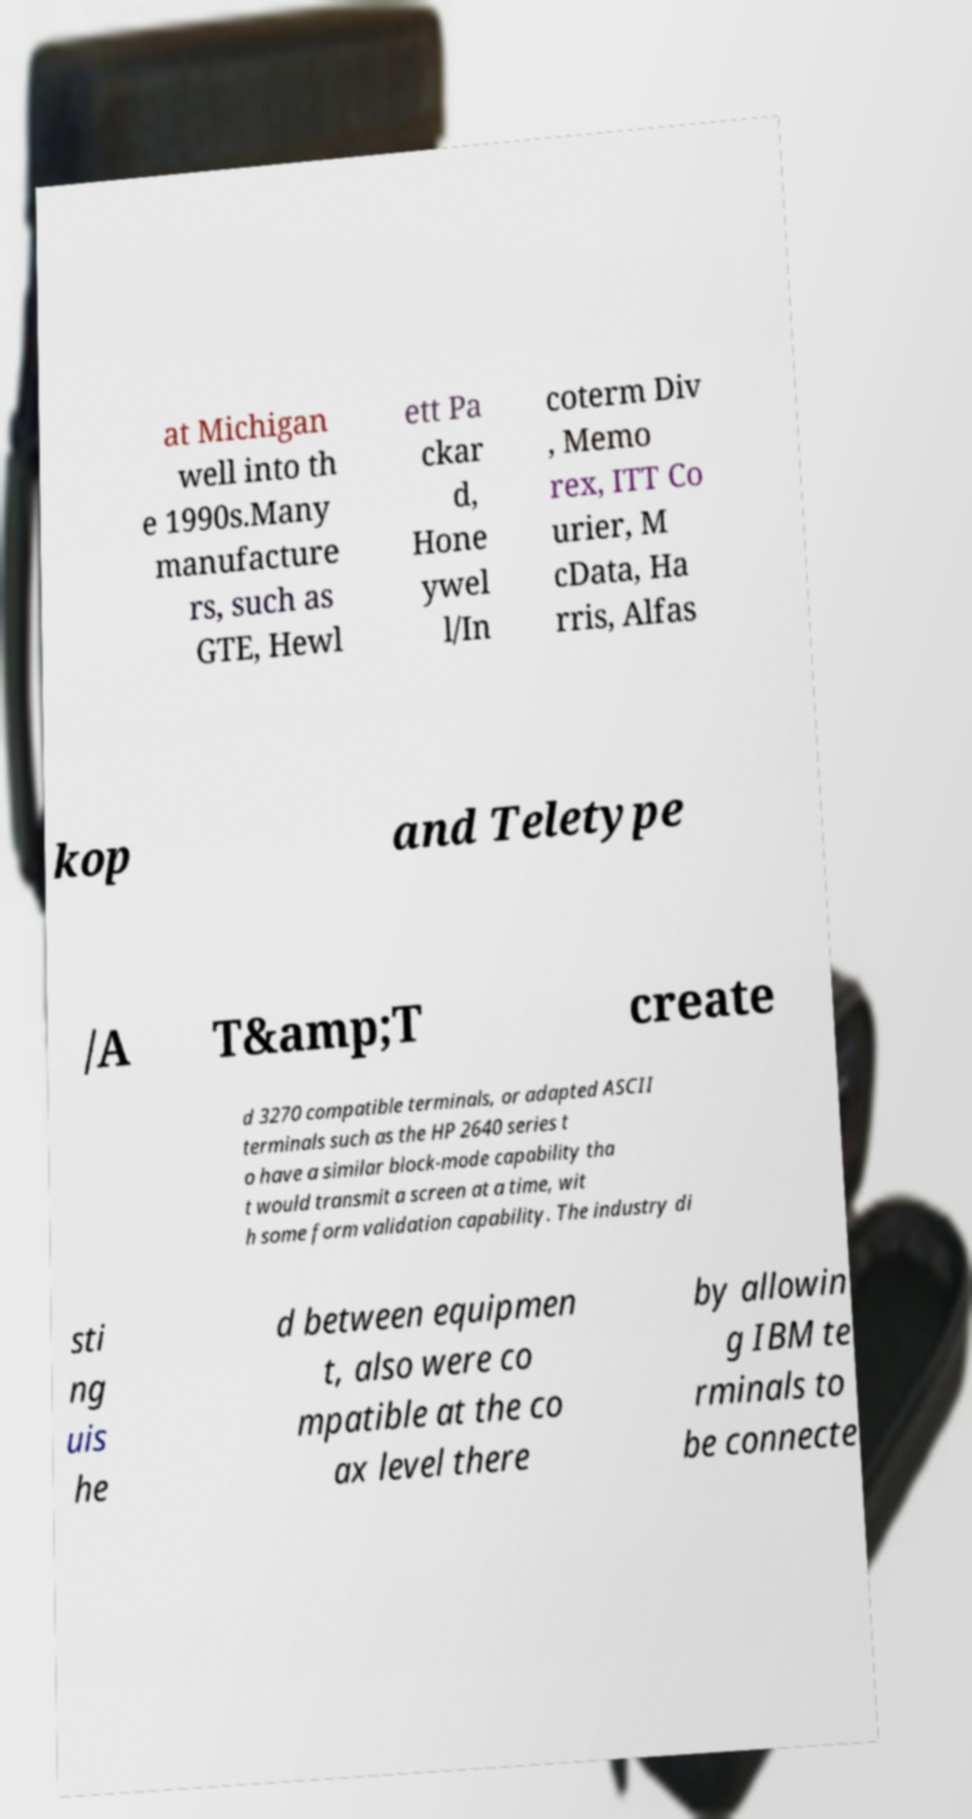Could you assist in decoding the text presented in this image and type it out clearly? at Michigan well into th e 1990s.Many manufacture rs, such as GTE, Hewl ett Pa ckar d, Hone ywel l/In coterm Div , Memo rex, ITT Co urier, M cData, Ha rris, Alfas kop and Teletype /A T&amp;T create d 3270 compatible terminals, or adapted ASCII terminals such as the HP 2640 series t o have a similar block-mode capability tha t would transmit a screen at a time, wit h some form validation capability. The industry di sti ng uis he d between equipmen t, also were co mpatible at the co ax level there by allowin g IBM te rminals to be connecte 